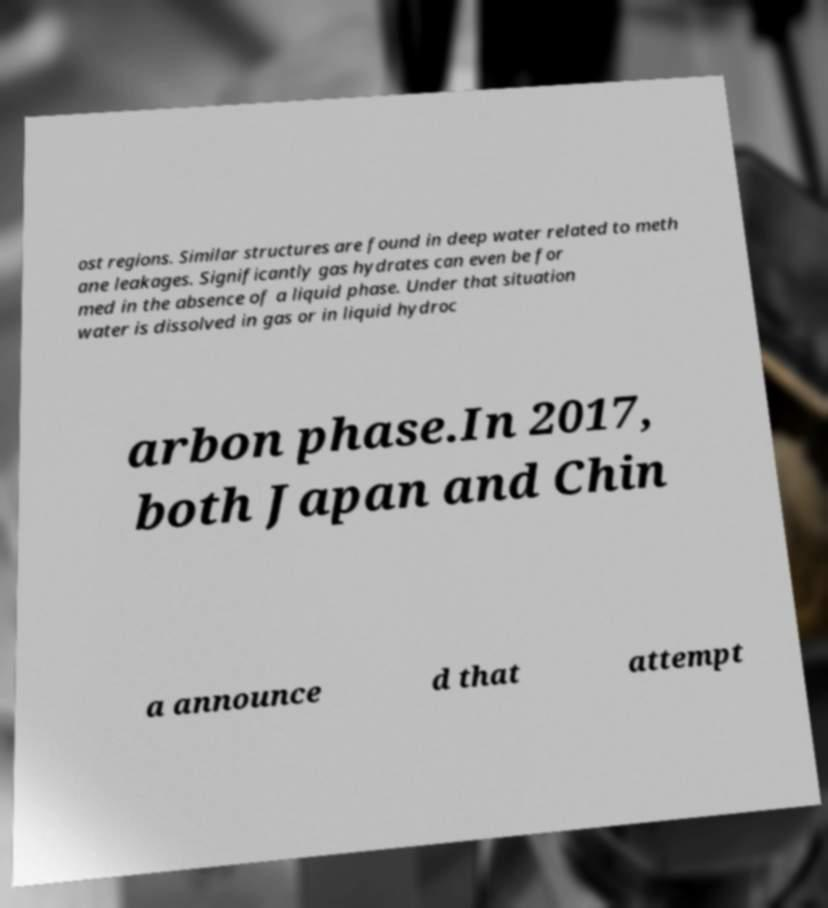Can you accurately transcribe the text from the provided image for me? ost regions. Similar structures are found in deep water related to meth ane leakages. Significantly gas hydrates can even be for med in the absence of a liquid phase. Under that situation water is dissolved in gas or in liquid hydroc arbon phase.In 2017, both Japan and Chin a announce d that attempt 